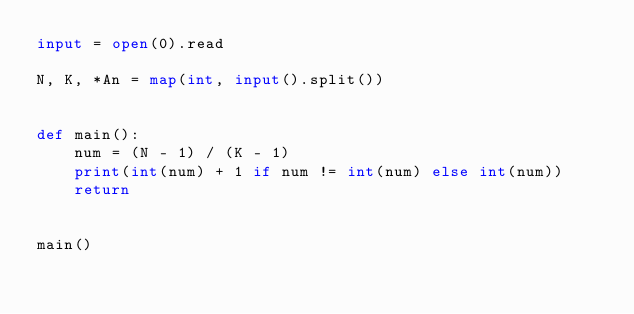<code> <loc_0><loc_0><loc_500><loc_500><_Python_>input = open(0).read

N, K, *An = map(int, input().split())


def main():
    num = (N - 1) / (K - 1)
    print(int(num) + 1 if num != int(num) else int(num))
    return


main()
</code> 